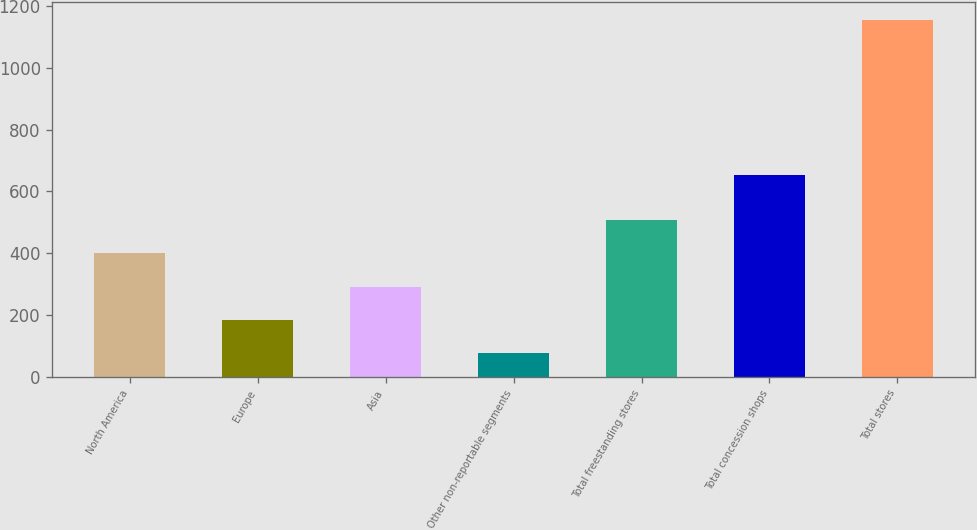Convert chart. <chart><loc_0><loc_0><loc_500><loc_500><bar_chart><fcel>North America<fcel>Europe<fcel>Asia<fcel>Other non-reportable segments<fcel>Total freestanding stores<fcel>Total concession shops<fcel>Total stores<nl><fcel>398.7<fcel>182.9<fcel>290.8<fcel>75<fcel>506.6<fcel>653<fcel>1154<nl></chart> 